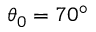<formula> <loc_0><loc_0><loc_500><loc_500>\theta _ { 0 } = 7 0 ^ { \circ }</formula> 